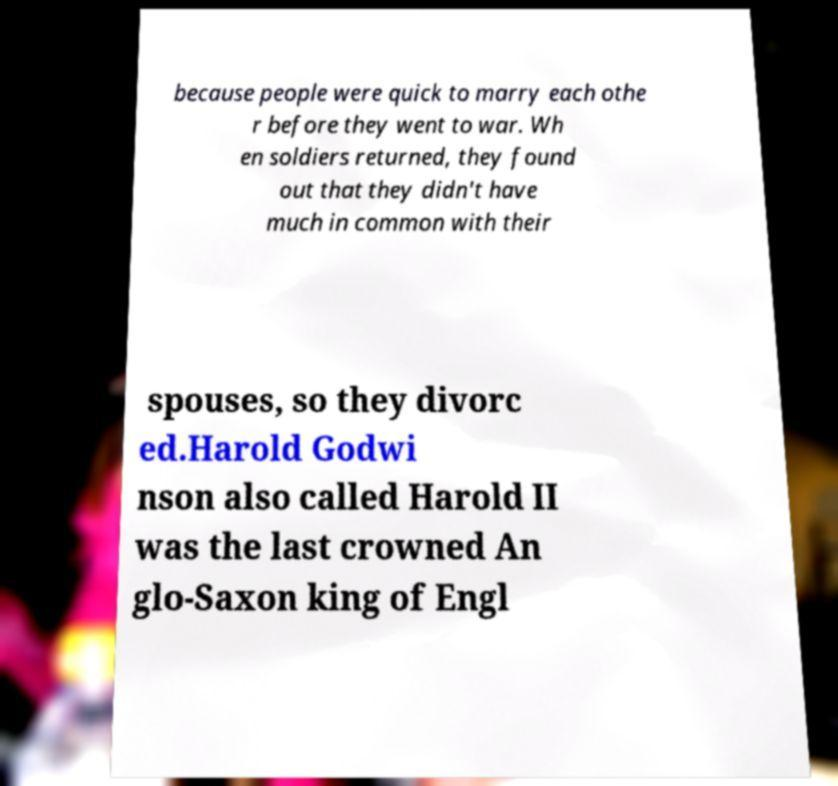Please read and relay the text visible in this image. What does it say? because people were quick to marry each othe r before they went to war. Wh en soldiers returned, they found out that they didn't have much in common with their spouses, so they divorc ed.Harold Godwi nson also called Harold II was the last crowned An glo-Saxon king of Engl 